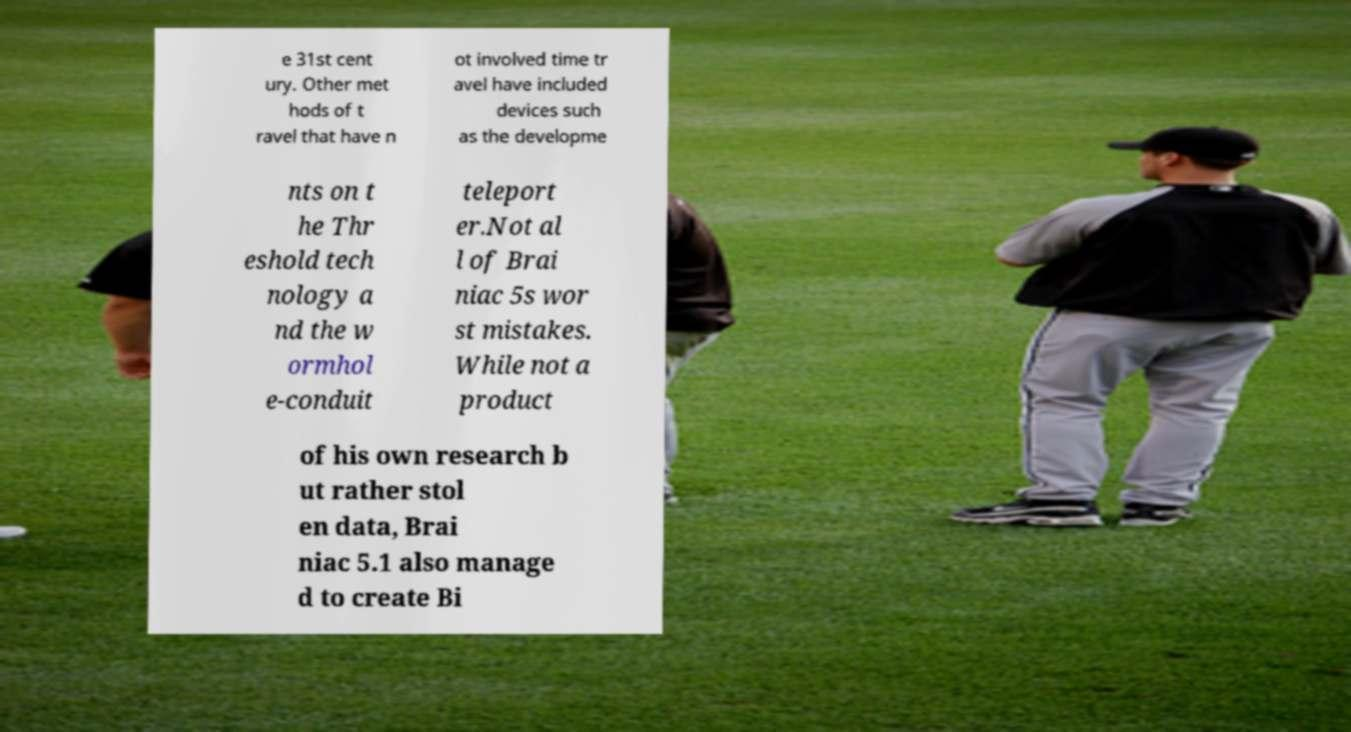Could you assist in decoding the text presented in this image and type it out clearly? e 31st cent ury. Other met hods of t ravel that have n ot involved time tr avel have included devices such as the developme nts on t he Thr eshold tech nology a nd the w ormhol e-conduit teleport er.Not al l of Brai niac 5s wor st mistakes. While not a product of his own research b ut rather stol en data, Brai niac 5.1 also manage d to create Bi 